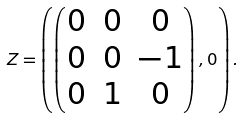Convert formula to latex. <formula><loc_0><loc_0><loc_500><loc_500>Z = \left ( \begin{pmatrix} 0 & 0 & 0 \\ 0 & 0 & - 1 \\ 0 & 1 & 0 \end{pmatrix} , 0 \right ) .</formula> 